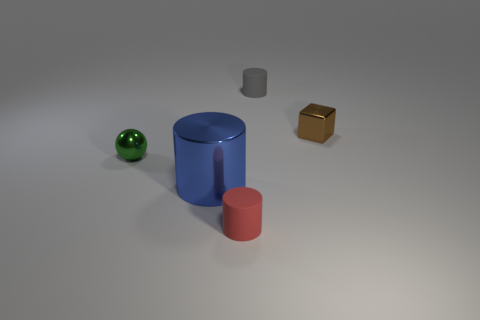Add 5 gray rubber cylinders. How many objects exist? 10 Subtract all cubes. How many objects are left? 4 Add 2 small brown blocks. How many small brown blocks are left? 3 Add 4 tiny green shiny things. How many tiny green shiny things exist? 5 Subtract 0 gray blocks. How many objects are left? 5 Subtract all purple things. Subtract all small brown shiny things. How many objects are left? 4 